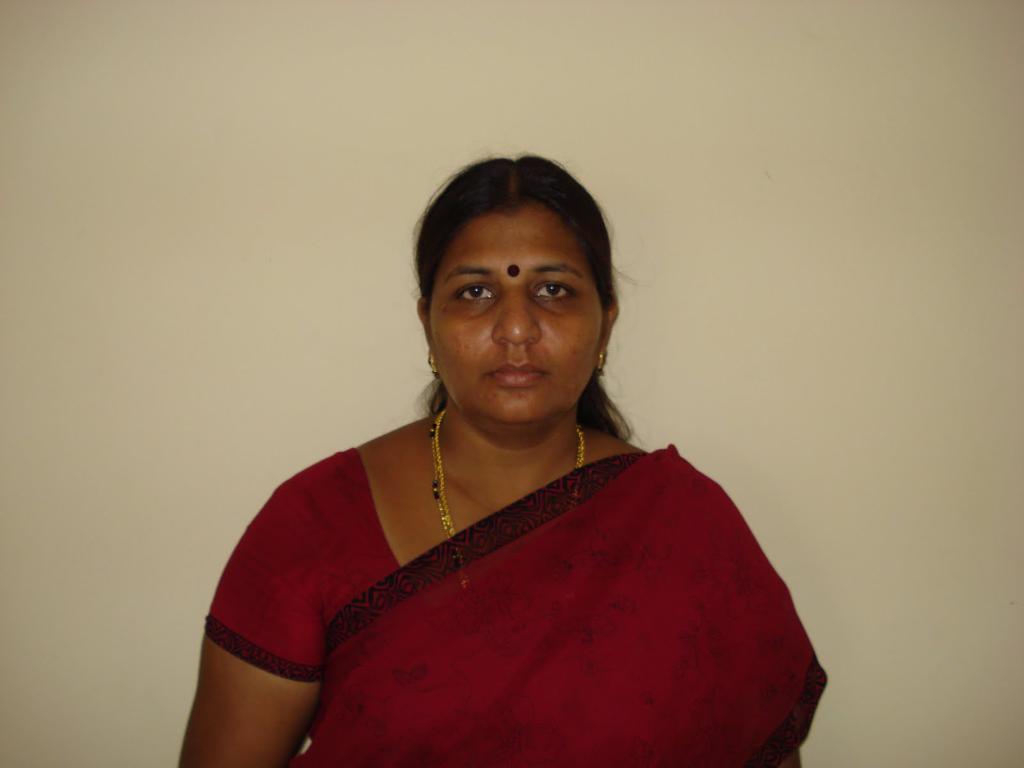How would you summarize this image in a sentence or two? In this image there is a lady in red saree. 